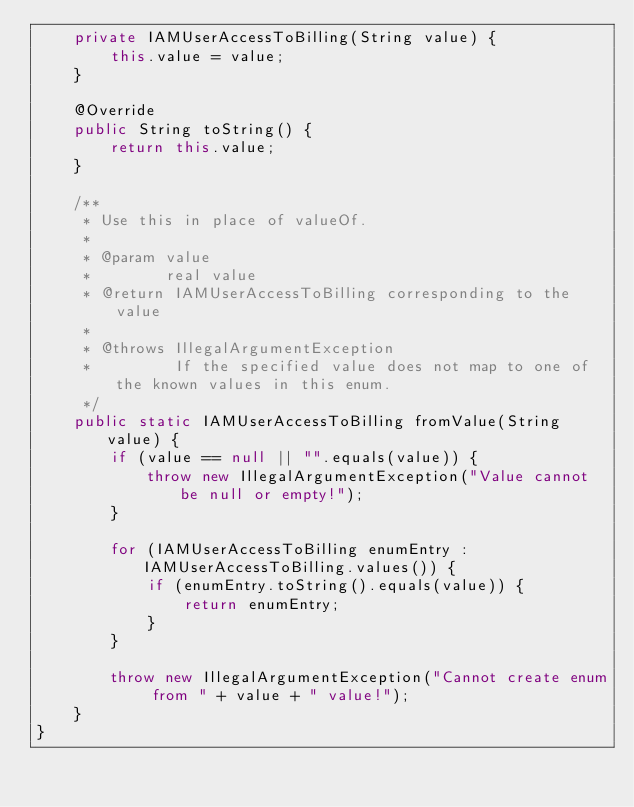<code> <loc_0><loc_0><loc_500><loc_500><_Java_>    private IAMUserAccessToBilling(String value) {
        this.value = value;
    }

    @Override
    public String toString() {
        return this.value;
    }

    /**
     * Use this in place of valueOf.
     *
     * @param value
     *        real value
     * @return IAMUserAccessToBilling corresponding to the value
     *
     * @throws IllegalArgumentException
     *         If the specified value does not map to one of the known values in this enum.
     */
    public static IAMUserAccessToBilling fromValue(String value) {
        if (value == null || "".equals(value)) {
            throw new IllegalArgumentException("Value cannot be null or empty!");
        }

        for (IAMUserAccessToBilling enumEntry : IAMUserAccessToBilling.values()) {
            if (enumEntry.toString().equals(value)) {
                return enumEntry;
            }
        }

        throw new IllegalArgumentException("Cannot create enum from " + value + " value!");
    }
}
</code> 